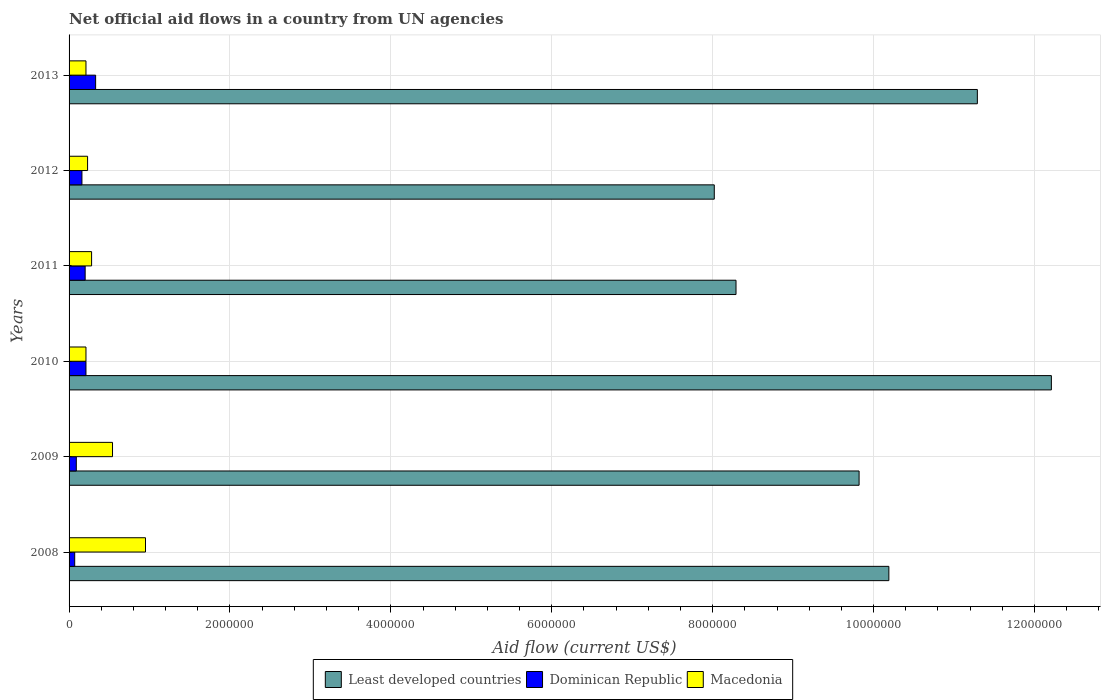In how many cases, is the number of bars for a given year not equal to the number of legend labels?
Your response must be concise. 0. What is the net official aid flow in Dominican Republic in 2008?
Your answer should be very brief. 7.00e+04. Across all years, what is the maximum net official aid flow in Macedonia?
Offer a terse response. 9.50e+05. Across all years, what is the minimum net official aid flow in Least developed countries?
Your answer should be compact. 8.02e+06. What is the total net official aid flow in Macedonia in the graph?
Ensure brevity in your answer.  2.42e+06. What is the difference between the net official aid flow in Least developed countries in 2008 and that in 2012?
Keep it short and to the point. 2.17e+06. What is the difference between the net official aid flow in Least developed countries in 2011 and the net official aid flow in Macedonia in 2008?
Make the answer very short. 7.34e+06. What is the average net official aid flow in Dominican Republic per year?
Offer a very short reply. 1.77e+05. In the year 2012, what is the difference between the net official aid flow in Macedonia and net official aid flow in Least developed countries?
Provide a short and direct response. -7.79e+06. In how many years, is the net official aid flow in Least developed countries greater than 10000000 US$?
Your answer should be very brief. 3. What is the ratio of the net official aid flow in Least developed countries in 2009 to that in 2010?
Provide a succinct answer. 0.8. What is the difference between the highest and the second highest net official aid flow in Dominican Republic?
Your response must be concise. 1.20e+05. What is the difference between the highest and the lowest net official aid flow in Macedonia?
Give a very brief answer. 7.40e+05. In how many years, is the net official aid flow in Least developed countries greater than the average net official aid flow in Least developed countries taken over all years?
Give a very brief answer. 3. Is the sum of the net official aid flow in Least developed countries in 2010 and 2011 greater than the maximum net official aid flow in Dominican Republic across all years?
Keep it short and to the point. Yes. What does the 3rd bar from the top in 2010 represents?
Your answer should be very brief. Least developed countries. What does the 3rd bar from the bottom in 2008 represents?
Give a very brief answer. Macedonia. Are all the bars in the graph horizontal?
Ensure brevity in your answer.  Yes. How many years are there in the graph?
Keep it short and to the point. 6. Does the graph contain grids?
Keep it short and to the point. Yes. How many legend labels are there?
Your answer should be very brief. 3. How are the legend labels stacked?
Provide a short and direct response. Horizontal. What is the title of the graph?
Ensure brevity in your answer.  Net official aid flows in a country from UN agencies. What is the Aid flow (current US$) in Least developed countries in 2008?
Your answer should be very brief. 1.02e+07. What is the Aid flow (current US$) in Macedonia in 2008?
Your answer should be very brief. 9.50e+05. What is the Aid flow (current US$) in Least developed countries in 2009?
Keep it short and to the point. 9.82e+06. What is the Aid flow (current US$) in Dominican Republic in 2009?
Provide a short and direct response. 9.00e+04. What is the Aid flow (current US$) in Macedonia in 2009?
Give a very brief answer. 5.40e+05. What is the Aid flow (current US$) in Least developed countries in 2010?
Offer a terse response. 1.22e+07. What is the Aid flow (current US$) of Dominican Republic in 2010?
Your answer should be compact. 2.10e+05. What is the Aid flow (current US$) of Macedonia in 2010?
Ensure brevity in your answer.  2.10e+05. What is the Aid flow (current US$) of Least developed countries in 2011?
Your answer should be compact. 8.29e+06. What is the Aid flow (current US$) of Dominican Republic in 2011?
Offer a terse response. 2.00e+05. What is the Aid flow (current US$) in Macedonia in 2011?
Ensure brevity in your answer.  2.80e+05. What is the Aid flow (current US$) in Least developed countries in 2012?
Your answer should be compact. 8.02e+06. What is the Aid flow (current US$) in Least developed countries in 2013?
Ensure brevity in your answer.  1.13e+07. What is the Aid flow (current US$) in Dominican Republic in 2013?
Keep it short and to the point. 3.30e+05. What is the Aid flow (current US$) in Macedonia in 2013?
Ensure brevity in your answer.  2.10e+05. Across all years, what is the maximum Aid flow (current US$) of Least developed countries?
Your answer should be very brief. 1.22e+07. Across all years, what is the maximum Aid flow (current US$) in Dominican Republic?
Keep it short and to the point. 3.30e+05. Across all years, what is the maximum Aid flow (current US$) in Macedonia?
Keep it short and to the point. 9.50e+05. Across all years, what is the minimum Aid flow (current US$) in Least developed countries?
Offer a terse response. 8.02e+06. What is the total Aid flow (current US$) in Least developed countries in the graph?
Ensure brevity in your answer.  5.98e+07. What is the total Aid flow (current US$) in Dominican Republic in the graph?
Your response must be concise. 1.06e+06. What is the total Aid flow (current US$) of Macedonia in the graph?
Offer a terse response. 2.42e+06. What is the difference between the Aid flow (current US$) of Least developed countries in 2008 and that in 2009?
Offer a terse response. 3.70e+05. What is the difference between the Aid flow (current US$) of Macedonia in 2008 and that in 2009?
Give a very brief answer. 4.10e+05. What is the difference between the Aid flow (current US$) in Least developed countries in 2008 and that in 2010?
Provide a short and direct response. -2.02e+06. What is the difference between the Aid flow (current US$) in Macedonia in 2008 and that in 2010?
Give a very brief answer. 7.40e+05. What is the difference between the Aid flow (current US$) of Least developed countries in 2008 and that in 2011?
Your answer should be very brief. 1.90e+06. What is the difference between the Aid flow (current US$) of Dominican Republic in 2008 and that in 2011?
Give a very brief answer. -1.30e+05. What is the difference between the Aid flow (current US$) of Macedonia in 2008 and that in 2011?
Give a very brief answer. 6.70e+05. What is the difference between the Aid flow (current US$) of Least developed countries in 2008 and that in 2012?
Your answer should be very brief. 2.17e+06. What is the difference between the Aid flow (current US$) in Macedonia in 2008 and that in 2012?
Your answer should be very brief. 7.20e+05. What is the difference between the Aid flow (current US$) of Least developed countries in 2008 and that in 2013?
Your answer should be compact. -1.10e+06. What is the difference between the Aid flow (current US$) of Macedonia in 2008 and that in 2013?
Provide a succinct answer. 7.40e+05. What is the difference between the Aid flow (current US$) of Least developed countries in 2009 and that in 2010?
Make the answer very short. -2.39e+06. What is the difference between the Aid flow (current US$) of Macedonia in 2009 and that in 2010?
Ensure brevity in your answer.  3.30e+05. What is the difference between the Aid flow (current US$) in Least developed countries in 2009 and that in 2011?
Provide a short and direct response. 1.53e+06. What is the difference between the Aid flow (current US$) of Dominican Republic in 2009 and that in 2011?
Offer a very short reply. -1.10e+05. What is the difference between the Aid flow (current US$) of Least developed countries in 2009 and that in 2012?
Your answer should be very brief. 1.80e+06. What is the difference between the Aid flow (current US$) of Macedonia in 2009 and that in 2012?
Your response must be concise. 3.10e+05. What is the difference between the Aid flow (current US$) of Least developed countries in 2009 and that in 2013?
Your answer should be compact. -1.47e+06. What is the difference between the Aid flow (current US$) of Dominican Republic in 2009 and that in 2013?
Provide a succinct answer. -2.40e+05. What is the difference between the Aid flow (current US$) in Macedonia in 2009 and that in 2013?
Provide a short and direct response. 3.30e+05. What is the difference between the Aid flow (current US$) in Least developed countries in 2010 and that in 2011?
Offer a terse response. 3.92e+06. What is the difference between the Aid flow (current US$) of Least developed countries in 2010 and that in 2012?
Offer a terse response. 4.19e+06. What is the difference between the Aid flow (current US$) in Dominican Republic in 2010 and that in 2012?
Ensure brevity in your answer.  5.00e+04. What is the difference between the Aid flow (current US$) in Least developed countries in 2010 and that in 2013?
Provide a succinct answer. 9.20e+05. What is the difference between the Aid flow (current US$) of Macedonia in 2010 and that in 2013?
Your answer should be very brief. 0. What is the difference between the Aid flow (current US$) in Least developed countries in 2011 and that in 2012?
Give a very brief answer. 2.70e+05. What is the difference between the Aid flow (current US$) of Dominican Republic in 2011 and that in 2013?
Provide a succinct answer. -1.30e+05. What is the difference between the Aid flow (current US$) in Least developed countries in 2012 and that in 2013?
Offer a terse response. -3.27e+06. What is the difference between the Aid flow (current US$) of Dominican Republic in 2012 and that in 2013?
Your answer should be very brief. -1.70e+05. What is the difference between the Aid flow (current US$) in Least developed countries in 2008 and the Aid flow (current US$) in Dominican Republic in 2009?
Offer a very short reply. 1.01e+07. What is the difference between the Aid flow (current US$) in Least developed countries in 2008 and the Aid flow (current US$) in Macedonia in 2009?
Provide a succinct answer. 9.65e+06. What is the difference between the Aid flow (current US$) of Dominican Republic in 2008 and the Aid flow (current US$) of Macedonia in 2009?
Make the answer very short. -4.70e+05. What is the difference between the Aid flow (current US$) in Least developed countries in 2008 and the Aid flow (current US$) in Dominican Republic in 2010?
Your answer should be very brief. 9.98e+06. What is the difference between the Aid flow (current US$) in Least developed countries in 2008 and the Aid flow (current US$) in Macedonia in 2010?
Keep it short and to the point. 9.98e+06. What is the difference between the Aid flow (current US$) in Dominican Republic in 2008 and the Aid flow (current US$) in Macedonia in 2010?
Your answer should be very brief. -1.40e+05. What is the difference between the Aid flow (current US$) in Least developed countries in 2008 and the Aid flow (current US$) in Dominican Republic in 2011?
Make the answer very short. 9.99e+06. What is the difference between the Aid flow (current US$) in Least developed countries in 2008 and the Aid flow (current US$) in Macedonia in 2011?
Provide a succinct answer. 9.91e+06. What is the difference between the Aid flow (current US$) in Least developed countries in 2008 and the Aid flow (current US$) in Dominican Republic in 2012?
Your answer should be compact. 1.00e+07. What is the difference between the Aid flow (current US$) of Least developed countries in 2008 and the Aid flow (current US$) of Macedonia in 2012?
Make the answer very short. 9.96e+06. What is the difference between the Aid flow (current US$) of Dominican Republic in 2008 and the Aid flow (current US$) of Macedonia in 2012?
Give a very brief answer. -1.60e+05. What is the difference between the Aid flow (current US$) of Least developed countries in 2008 and the Aid flow (current US$) of Dominican Republic in 2013?
Offer a very short reply. 9.86e+06. What is the difference between the Aid flow (current US$) of Least developed countries in 2008 and the Aid flow (current US$) of Macedonia in 2013?
Offer a terse response. 9.98e+06. What is the difference between the Aid flow (current US$) in Least developed countries in 2009 and the Aid flow (current US$) in Dominican Republic in 2010?
Offer a very short reply. 9.61e+06. What is the difference between the Aid flow (current US$) in Least developed countries in 2009 and the Aid flow (current US$) in Macedonia in 2010?
Your answer should be very brief. 9.61e+06. What is the difference between the Aid flow (current US$) in Dominican Republic in 2009 and the Aid flow (current US$) in Macedonia in 2010?
Offer a terse response. -1.20e+05. What is the difference between the Aid flow (current US$) of Least developed countries in 2009 and the Aid flow (current US$) of Dominican Republic in 2011?
Provide a succinct answer. 9.62e+06. What is the difference between the Aid flow (current US$) of Least developed countries in 2009 and the Aid flow (current US$) of Macedonia in 2011?
Make the answer very short. 9.54e+06. What is the difference between the Aid flow (current US$) in Dominican Republic in 2009 and the Aid flow (current US$) in Macedonia in 2011?
Give a very brief answer. -1.90e+05. What is the difference between the Aid flow (current US$) of Least developed countries in 2009 and the Aid flow (current US$) of Dominican Republic in 2012?
Provide a succinct answer. 9.66e+06. What is the difference between the Aid flow (current US$) in Least developed countries in 2009 and the Aid flow (current US$) in Macedonia in 2012?
Give a very brief answer. 9.59e+06. What is the difference between the Aid flow (current US$) of Least developed countries in 2009 and the Aid flow (current US$) of Dominican Republic in 2013?
Your response must be concise. 9.49e+06. What is the difference between the Aid flow (current US$) in Least developed countries in 2009 and the Aid flow (current US$) in Macedonia in 2013?
Offer a terse response. 9.61e+06. What is the difference between the Aid flow (current US$) in Least developed countries in 2010 and the Aid flow (current US$) in Dominican Republic in 2011?
Provide a short and direct response. 1.20e+07. What is the difference between the Aid flow (current US$) of Least developed countries in 2010 and the Aid flow (current US$) of Macedonia in 2011?
Your response must be concise. 1.19e+07. What is the difference between the Aid flow (current US$) in Least developed countries in 2010 and the Aid flow (current US$) in Dominican Republic in 2012?
Make the answer very short. 1.20e+07. What is the difference between the Aid flow (current US$) in Least developed countries in 2010 and the Aid flow (current US$) in Macedonia in 2012?
Your answer should be very brief. 1.20e+07. What is the difference between the Aid flow (current US$) in Dominican Republic in 2010 and the Aid flow (current US$) in Macedonia in 2012?
Ensure brevity in your answer.  -2.00e+04. What is the difference between the Aid flow (current US$) in Least developed countries in 2010 and the Aid flow (current US$) in Dominican Republic in 2013?
Ensure brevity in your answer.  1.19e+07. What is the difference between the Aid flow (current US$) in Least developed countries in 2010 and the Aid flow (current US$) in Macedonia in 2013?
Give a very brief answer. 1.20e+07. What is the difference between the Aid flow (current US$) in Least developed countries in 2011 and the Aid flow (current US$) in Dominican Republic in 2012?
Make the answer very short. 8.13e+06. What is the difference between the Aid flow (current US$) of Least developed countries in 2011 and the Aid flow (current US$) of Macedonia in 2012?
Your answer should be compact. 8.06e+06. What is the difference between the Aid flow (current US$) in Dominican Republic in 2011 and the Aid flow (current US$) in Macedonia in 2012?
Ensure brevity in your answer.  -3.00e+04. What is the difference between the Aid flow (current US$) in Least developed countries in 2011 and the Aid flow (current US$) in Dominican Republic in 2013?
Provide a short and direct response. 7.96e+06. What is the difference between the Aid flow (current US$) of Least developed countries in 2011 and the Aid flow (current US$) of Macedonia in 2013?
Your answer should be very brief. 8.08e+06. What is the difference between the Aid flow (current US$) of Least developed countries in 2012 and the Aid flow (current US$) of Dominican Republic in 2013?
Ensure brevity in your answer.  7.69e+06. What is the difference between the Aid flow (current US$) in Least developed countries in 2012 and the Aid flow (current US$) in Macedonia in 2013?
Provide a short and direct response. 7.81e+06. What is the average Aid flow (current US$) of Least developed countries per year?
Ensure brevity in your answer.  9.97e+06. What is the average Aid flow (current US$) in Dominican Republic per year?
Make the answer very short. 1.77e+05. What is the average Aid flow (current US$) in Macedonia per year?
Offer a very short reply. 4.03e+05. In the year 2008, what is the difference between the Aid flow (current US$) in Least developed countries and Aid flow (current US$) in Dominican Republic?
Your answer should be very brief. 1.01e+07. In the year 2008, what is the difference between the Aid flow (current US$) in Least developed countries and Aid flow (current US$) in Macedonia?
Keep it short and to the point. 9.24e+06. In the year 2008, what is the difference between the Aid flow (current US$) of Dominican Republic and Aid flow (current US$) of Macedonia?
Make the answer very short. -8.80e+05. In the year 2009, what is the difference between the Aid flow (current US$) of Least developed countries and Aid flow (current US$) of Dominican Republic?
Offer a very short reply. 9.73e+06. In the year 2009, what is the difference between the Aid flow (current US$) in Least developed countries and Aid flow (current US$) in Macedonia?
Your answer should be very brief. 9.28e+06. In the year 2009, what is the difference between the Aid flow (current US$) of Dominican Republic and Aid flow (current US$) of Macedonia?
Offer a very short reply. -4.50e+05. In the year 2010, what is the difference between the Aid flow (current US$) in Least developed countries and Aid flow (current US$) in Dominican Republic?
Provide a short and direct response. 1.20e+07. In the year 2010, what is the difference between the Aid flow (current US$) of Least developed countries and Aid flow (current US$) of Macedonia?
Ensure brevity in your answer.  1.20e+07. In the year 2010, what is the difference between the Aid flow (current US$) in Dominican Republic and Aid flow (current US$) in Macedonia?
Your answer should be very brief. 0. In the year 2011, what is the difference between the Aid flow (current US$) of Least developed countries and Aid flow (current US$) of Dominican Republic?
Make the answer very short. 8.09e+06. In the year 2011, what is the difference between the Aid flow (current US$) of Least developed countries and Aid flow (current US$) of Macedonia?
Offer a terse response. 8.01e+06. In the year 2011, what is the difference between the Aid flow (current US$) in Dominican Republic and Aid flow (current US$) in Macedonia?
Make the answer very short. -8.00e+04. In the year 2012, what is the difference between the Aid flow (current US$) in Least developed countries and Aid flow (current US$) in Dominican Republic?
Your response must be concise. 7.86e+06. In the year 2012, what is the difference between the Aid flow (current US$) of Least developed countries and Aid flow (current US$) of Macedonia?
Offer a terse response. 7.79e+06. In the year 2012, what is the difference between the Aid flow (current US$) of Dominican Republic and Aid flow (current US$) of Macedonia?
Ensure brevity in your answer.  -7.00e+04. In the year 2013, what is the difference between the Aid flow (current US$) of Least developed countries and Aid flow (current US$) of Dominican Republic?
Keep it short and to the point. 1.10e+07. In the year 2013, what is the difference between the Aid flow (current US$) of Least developed countries and Aid flow (current US$) of Macedonia?
Ensure brevity in your answer.  1.11e+07. In the year 2013, what is the difference between the Aid flow (current US$) of Dominican Republic and Aid flow (current US$) of Macedonia?
Provide a succinct answer. 1.20e+05. What is the ratio of the Aid flow (current US$) of Least developed countries in 2008 to that in 2009?
Offer a terse response. 1.04. What is the ratio of the Aid flow (current US$) in Macedonia in 2008 to that in 2009?
Your response must be concise. 1.76. What is the ratio of the Aid flow (current US$) of Least developed countries in 2008 to that in 2010?
Provide a short and direct response. 0.83. What is the ratio of the Aid flow (current US$) of Macedonia in 2008 to that in 2010?
Your response must be concise. 4.52. What is the ratio of the Aid flow (current US$) in Least developed countries in 2008 to that in 2011?
Your answer should be compact. 1.23. What is the ratio of the Aid flow (current US$) in Macedonia in 2008 to that in 2011?
Keep it short and to the point. 3.39. What is the ratio of the Aid flow (current US$) in Least developed countries in 2008 to that in 2012?
Keep it short and to the point. 1.27. What is the ratio of the Aid flow (current US$) of Dominican Republic in 2008 to that in 2012?
Your answer should be compact. 0.44. What is the ratio of the Aid flow (current US$) of Macedonia in 2008 to that in 2012?
Offer a terse response. 4.13. What is the ratio of the Aid flow (current US$) in Least developed countries in 2008 to that in 2013?
Provide a succinct answer. 0.9. What is the ratio of the Aid flow (current US$) in Dominican Republic in 2008 to that in 2013?
Offer a terse response. 0.21. What is the ratio of the Aid flow (current US$) in Macedonia in 2008 to that in 2013?
Offer a very short reply. 4.52. What is the ratio of the Aid flow (current US$) of Least developed countries in 2009 to that in 2010?
Give a very brief answer. 0.8. What is the ratio of the Aid flow (current US$) of Dominican Republic in 2009 to that in 2010?
Ensure brevity in your answer.  0.43. What is the ratio of the Aid flow (current US$) in Macedonia in 2009 to that in 2010?
Give a very brief answer. 2.57. What is the ratio of the Aid flow (current US$) in Least developed countries in 2009 to that in 2011?
Your answer should be very brief. 1.18. What is the ratio of the Aid flow (current US$) of Dominican Republic in 2009 to that in 2011?
Provide a succinct answer. 0.45. What is the ratio of the Aid flow (current US$) in Macedonia in 2009 to that in 2011?
Give a very brief answer. 1.93. What is the ratio of the Aid flow (current US$) of Least developed countries in 2009 to that in 2012?
Offer a terse response. 1.22. What is the ratio of the Aid flow (current US$) in Dominican Republic in 2009 to that in 2012?
Your answer should be very brief. 0.56. What is the ratio of the Aid flow (current US$) in Macedonia in 2009 to that in 2012?
Keep it short and to the point. 2.35. What is the ratio of the Aid flow (current US$) in Least developed countries in 2009 to that in 2013?
Make the answer very short. 0.87. What is the ratio of the Aid flow (current US$) in Dominican Republic in 2009 to that in 2013?
Provide a short and direct response. 0.27. What is the ratio of the Aid flow (current US$) of Macedonia in 2009 to that in 2013?
Provide a succinct answer. 2.57. What is the ratio of the Aid flow (current US$) in Least developed countries in 2010 to that in 2011?
Provide a short and direct response. 1.47. What is the ratio of the Aid flow (current US$) in Dominican Republic in 2010 to that in 2011?
Provide a short and direct response. 1.05. What is the ratio of the Aid flow (current US$) in Macedonia in 2010 to that in 2011?
Offer a terse response. 0.75. What is the ratio of the Aid flow (current US$) in Least developed countries in 2010 to that in 2012?
Keep it short and to the point. 1.52. What is the ratio of the Aid flow (current US$) of Dominican Republic in 2010 to that in 2012?
Provide a short and direct response. 1.31. What is the ratio of the Aid flow (current US$) in Least developed countries in 2010 to that in 2013?
Offer a very short reply. 1.08. What is the ratio of the Aid flow (current US$) in Dominican Republic in 2010 to that in 2013?
Ensure brevity in your answer.  0.64. What is the ratio of the Aid flow (current US$) in Least developed countries in 2011 to that in 2012?
Give a very brief answer. 1.03. What is the ratio of the Aid flow (current US$) in Dominican Republic in 2011 to that in 2012?
Your answer should be very brief. 1.25. What is the ratio of the Aid flow (current US$) in Macedonia in 2011 to that in 2012?
Give a very brief answer. 1.22. What is the ratio of the Aid flow (current US$) in Least developed countries in 2011 to that in 2013?
Make the answer very short. 0.73. What is the ratio of the Aid flow (current US$) in Dominican Republic in 2011 to that in 2013?
Your answer should be very brief. 0.61. What is the ratio of the Aid flow (current US$) of Macedonia in 2011 to that in 2013?
Keep it short and to the point. 1.33. What is the ratio of the Aid flow (current US$) in Least developed countries in 2012 to that in 2013?
Provide a short and direct response. 0.71. What is the ratio of the Aid flow (current US$) of Dominican Republic in 2012 to that in 2013?
Keep it short and to the point. 0.48. What is the ratio of the Aid flow (current US$) of Macedonia in 2012 to that in 2013?
Give a very brief answer. 1.1. What is the difference between the highest and the second highest Aid flow (current US$) in Least developed countries?
Your answer should be very brief. 9.20e+05. What is the difference between the highest and the second highest Aid flow (current US$) in Dominican Republic?
Give a very brief answer. 1.20e+05. What is the difference between the highest and the second highest Aid flow (current US$) in Macedonia?
Offer a very short reply. 4.10e+05. What is the difference between the highest and the lowest Aid flow (current US$) of Least developed countries?
Your answer should be compact. 4.19e+06. What is the difference between the highest and the lowest Aid flow (current US$) in Dominican Republic?
Provide a succinct answer. 2.60e+05. What is the difference between the highest and the lowest Aid flow (current US$) in Macedonia?
Offer a terse response. 7.40e+05. 